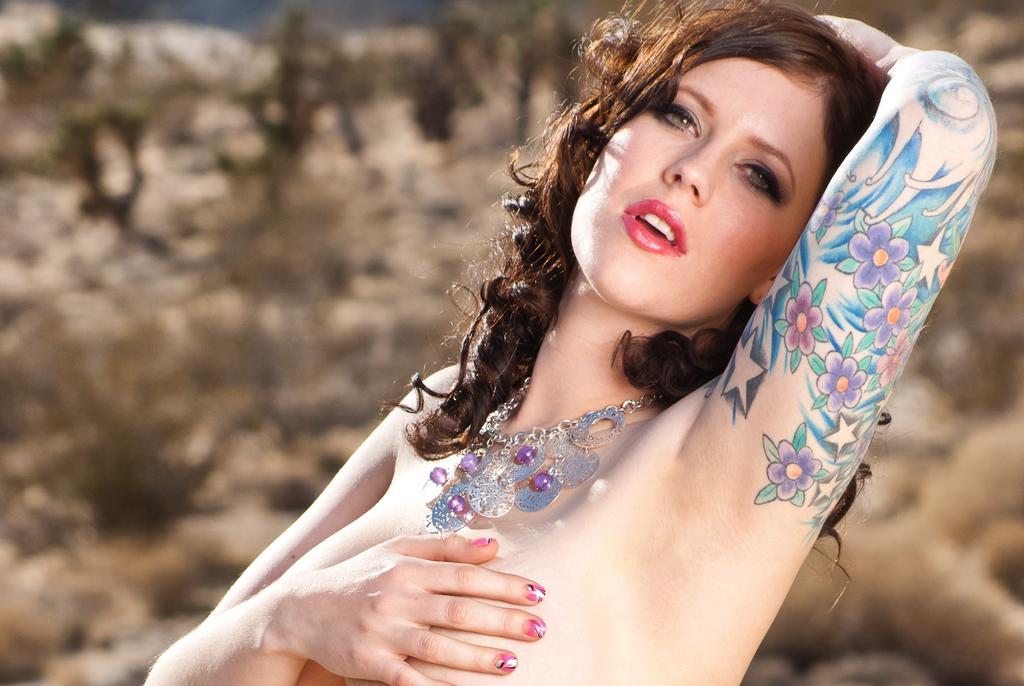Can you describe this image briefly? In this image I can see a person, the person is wearing the jewellery and a colorful tattoo on the hand and I can see blurred background. 